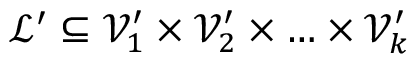Convert formula to latex. <formula><loc_0><loc_0><loc_500><loc_500>\mathcal { L } ^ { \prime } \subseteq \mathcal { V } _ { 1 } ^ { \prime } \times \mathcal { V } _ { 2 } ^ { \prime } \times \dots \times \mathcal { V } _ { k } ^ { \prime }</formula> 